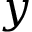<formula> <loc_0><loc_0><loc_500><loc_500>y</formula> 